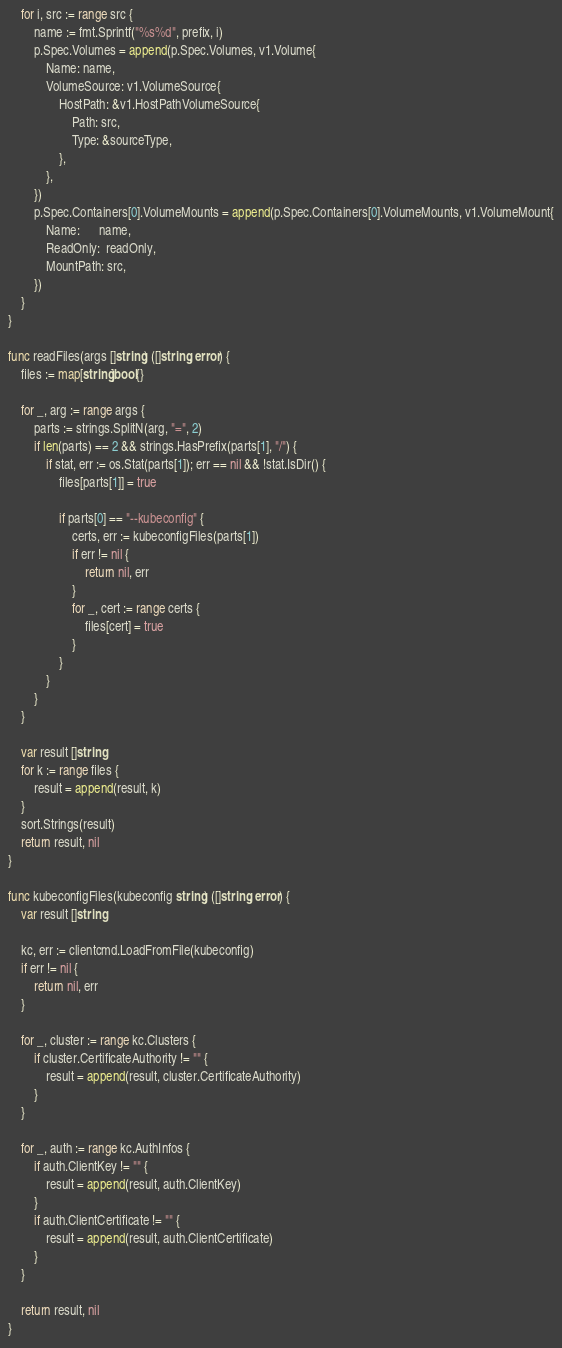Convert code to text. <code><loc_0><loc_0><loc_500><loc_500><_Go_>	for i, src := range src {
		name := fmt.Sprintf("%s%d", prefix, i)
		p.Spec.Volumes = append(p.Spec.Volumes, v1.Volume{
			Name: name,
			VolumeSource: v1.VolumeSource{
				HostPath: &v1.HostPathVolumeSource{
					Path: src,
					Type: &sourceType,
				},
			},
		})
		p.Spec.Containers[0].VolumeMounts = append(p.Spec.Containers[0].VolumeMounts, v1.VolumeMount{
			Name:      name,
			ReadOnly:  readOnly,
			MountPath: src,
		})
	}
}

func readFiles(args []string) ([]string, error) {
	files := map[string]bool{}

	for _, arg := range args {
		parts := strings.SplitN(arg, "=", 2)
		if len(parts) == 2 && strings.HasPrefix(parts[1], "/") {
			if stat, err := os.Stat(parts[1]); err == nil && !stat.IsDir() {
				files[parts[1]] = true

				if parts[0] == "--kubeconfig" {
					certs, err := kubeconfigFiles(parts[1])
					if err != nil {
						return nil, err
					}
					for _, cert := range certs {
						files[cert] = true
					}
				}
			}
		}
	}

	var result []string
	for k := range files {
		result = append(result, k)
	}
	sort.Strings(result)
	return result, nil
}

func kubeconfigFiles(kubeconfig string) ([]string, error) {
	var result []string

	kc, err := clientcmd.LoadFromFile(kubeconfig)
	if err != nil {
		return nil, err
	}

	for _, cluster := range kc.Clusters {
		if cluster.CertificateAuthority != "" {
			result = append(result, cluster.CertificateAuthority)
		}
	}

	for _, auth := range kc.AuthInfos {
		if auth.ClientKey != "" {
			result = append(result, auth.ClientKey)
		}
		if auth.ClientCertificate != "" {
			result = append(result, auth.ClientCertificate)
		}
	}

	return result, nil
}
</code> 